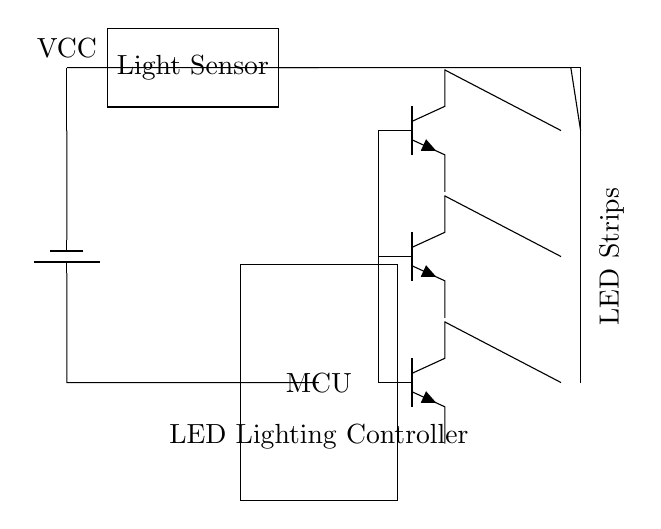What type of microcontroller is used in this circuit? The circuit diagram specifies a general "MCU" as the microcontroller without detailing its specific model; hence it is referred to simply as "MCU."
Answer: MCU How many transistors are there in the circuit? The circuit shows three transistors labeled as q1, q2, and q3. Therefore, the total number of transistors is three.
Answer: 3 What is the function of the light sensor? The light sensor's role is to detect ambient light levels in the environment, which the microcontroller uses for controlling the LED illumination based on light conditions.
Answer: Detect ambient light What components control the LED strips? The LED strips are controlled by the three transistors (q1, q2, and q3), which act as switches based on signals from the microcontroller (MCU).
Answer: Transistors What is the voltage source for this circuit? The circuit uses a battery, indicated as "VCC," which supplies the power necessary to operate the light sensor and the LEDs.
Answer: Battery How are the LEDs connected to the circuit? The LEDs are connected in such a way that their collectors are attached to the corresponding transistors, allowing them to be turned on or off through the control of these transistors.
Answer: Through transistors What is the primary purpose of this circuit? The primary purpose of this circuit is to control outdoor landscape illumination using LED lighting based on detected light levels, enhancing energy efficiency and functionality.
Answer: Control outdoor lighting 